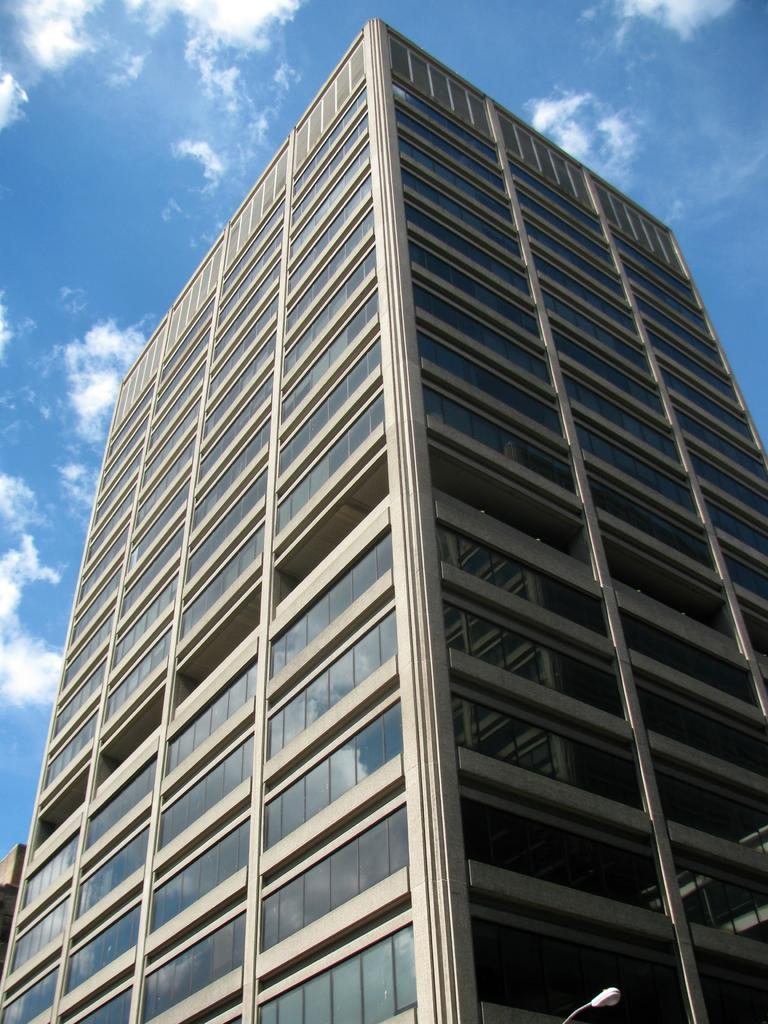Where was the image taken? The image is taken outdoors. What can be seen at the top of the image? The sky is visible at the top of the image. What is the condition of the sky in the image? There are clouds in the sky. What is the main subject in the middle of the image? There is a skyscraper in the middle of the image. How many boys are shaking hands in the image? There are no boys or handshakes present in the image. What type of meal is being served in the image? There is no meal present in the image. 